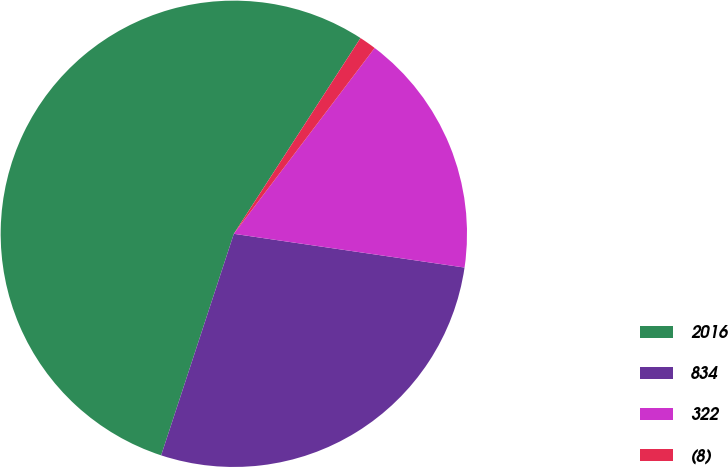Convert chart to OTSL. <chart><loc_0><loc_0><loc_500><loc_500><pie_chart><fcel>2016<fcel>834<fcel>322<fcel>(8)<nl><fcel>54.09%<fcel>27.73%<fcel>16.99%<fcel>1.18%<nl></chart> 